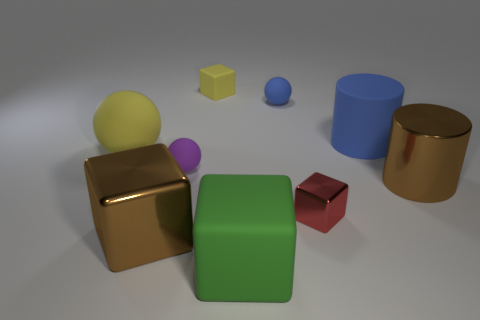Add 1 tiny red metallic objects. How many objects exist? 10 Subtract all spheres. How many objects are left? 6 Add 1 large blue rubber cylinders. How many large blue rubber cylinders exist? 2 Subtract 1 red cubes. How many objects are left? 8 Subtract all big blocks. Subtract all tiny yellow rubber cylinders. How many objects are left? 7 Add 7 tiny rubber objects. How many tiny rubber objects are left? 10 